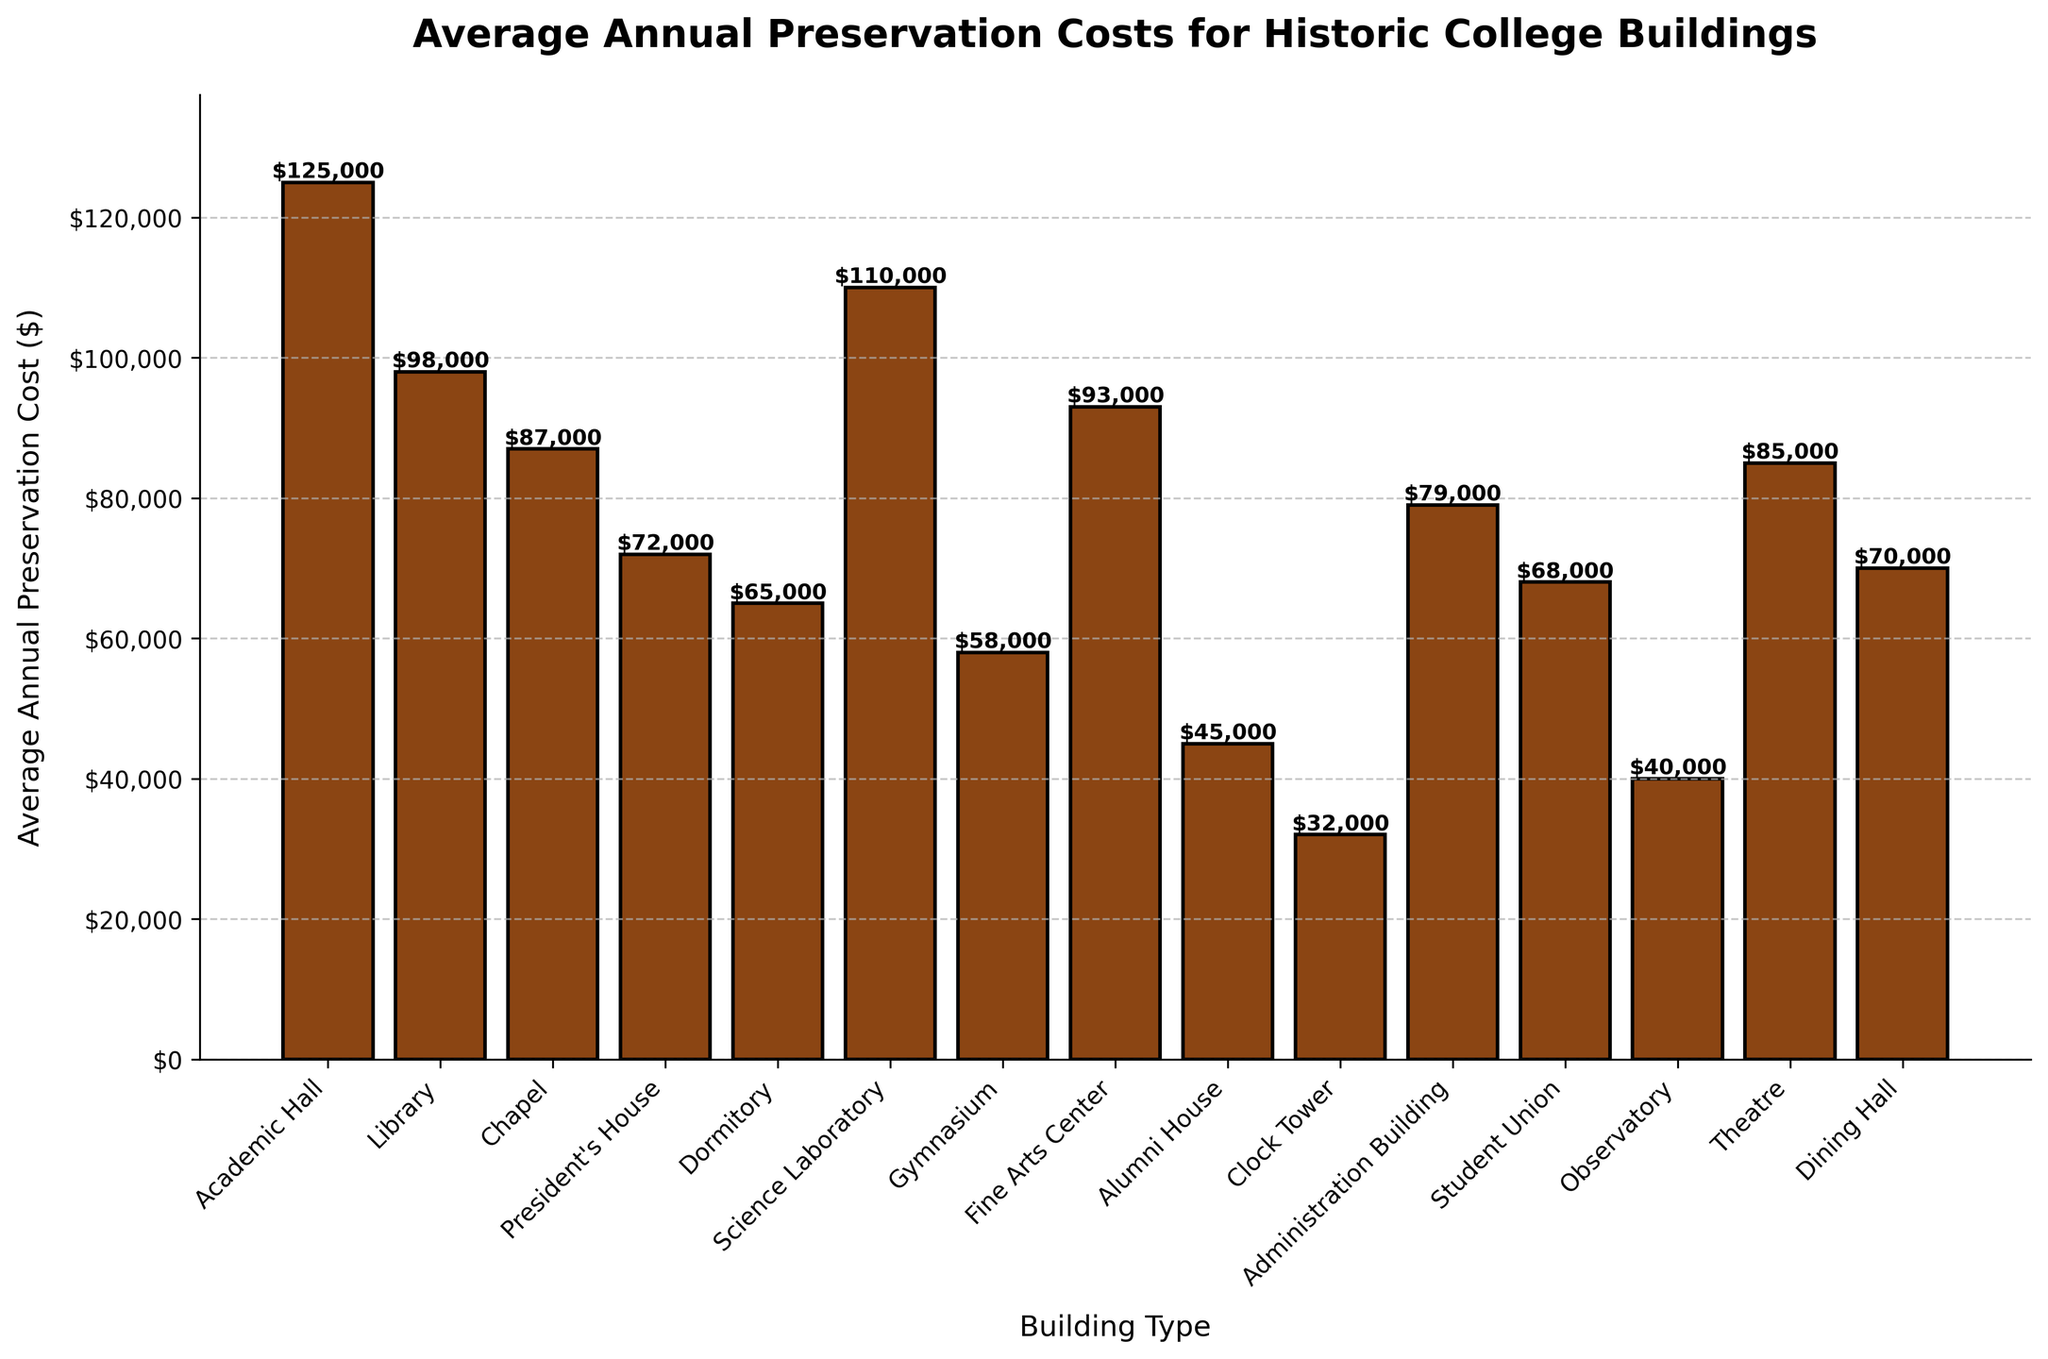Which building type has the highest preservation cost? Identify the tallest bar in the bar chart, which represents the building with the highest preservation cost.
Answer: Academic Hall Which building type has the lowest preservation cost? Identify the shortest bar in the bar chart, which represents the building with the lowest preservation cost.
Answer: Clock Tower What is the combined preservation cost of the Library and the Science Laboratory? Find the heights of the bars representing the Library and the Science Laboratory and sum these values.
Answer: $208,000 Which buildings have preservation costs higher than $80,000 but lower than $100,000? Identify the bars whose heights fall between $80,000 and $100,000.
Answer: Chapel, Fine Arts Center, Theatre Are the preservation costs for the President's House and the Administration Building equal? Compare the heights of the bars for the President's House and the Administration Building.
Answer: No What is the difference in preservation costs between the Gymnasium and the Dormitory? Find the heights of the bars for the Gymnasium and the Dormitory and calculate the difference.
Answer: $7,000 Is the preservation cost for the Student Union higher or lower than that for the Dining Hall? Compare the heights of the bars for the Student Union and the Dining Hall.
Answer: Higher What is the average preservation cost for the Fine Arts Center and the Science Laboratory? Find the heights of the bars for the Fine Arts Center and the Science Laboratory, sum them up, and divide by 2.
Answer: $101,500 Which building type has a preservation cost closest to $70,000? Identify the bar whose height is closest to $70,000.
Answer: Dining Hall What is the sum of the preservation costs for the Chapel, Theatre, and President's House? Find the heights of the bars for the Chapel, Theatre, and President's House and sum these values.
Answer: $244,000 